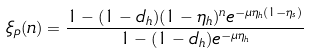<formula> <loc_0><loc_0><loc_500><loc_500>\xi _ { p } ( n ) = \frac { 1 - ( 1 - d _ { h } ) ( 1 - \eta _ { h } ) ^ { n } e ^ { - \mu \eta _ { h } ( 1 - \eta _ { s } ) } } { 1 - ( 1 - d _ { h } ) e ^ { - \mu \eta _ { h } } }</formula> 